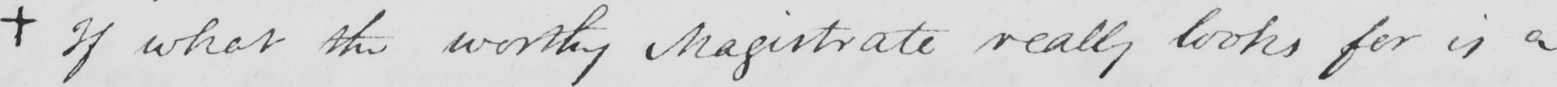Please provide the text content of this handwritten line. +  If what the worthy Magistrate really looks for is a 